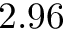Convert formula to latex. <formula><loc_0><loc_0><loc_500><loc_500>2 . 9 6</formula> 